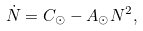<formula> <loc_0><loc_0><loc_500><loc_500>\dot { N } = C _ { \odot } - A _ { \odot } N ^ { 2 } ,</formula> 